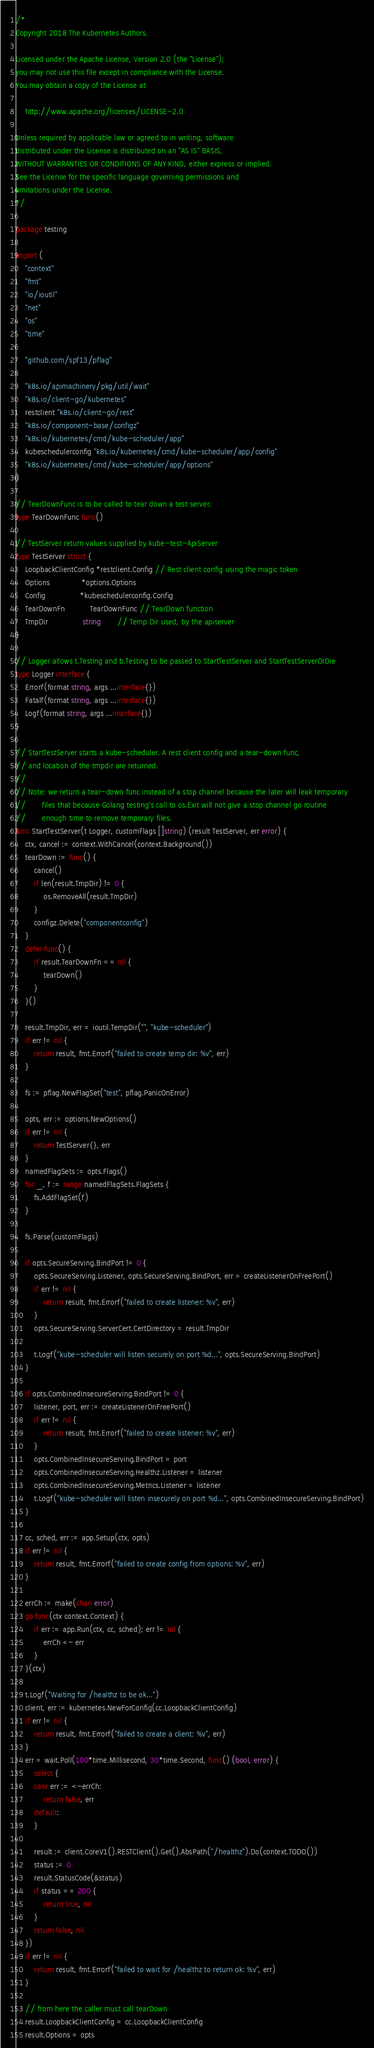Convert code to text. <code><loc_0><loc_0><loc_500><loc_500><_Go_>/*
Copyright 2018 The Kubernetes Authors.

Licensed under the Apache License, Version 2.0 (the "License");
you may not use this file except in compliance with the License.
You may obtain a copy of the License at

    http://www.apache.org/licenses/LICENSE-2.0

Unless required by applicable law or agreed to in writing, software
distributed under the License is distributed on an "AS IS" BASIS,
WITHOUT WARRANTIES OR CONDITIONS OF ANY KIND, either express or implied.
See the License for the specific language governing permissions and
limitations under the License.
*/

package testing

import (
	"context"
	"fmt"
	"io/ioutil"
	"net"
	"os"
	"time"

	"github.com/spf13/pflag"

	"k8s.io/apimachinery/pkg/util/wait"
	"k8s.io/client-go/kubernetes"
	restclient "k8s.io/client-go/rest"
	"k8s.io/component-base/configz"
	"k8s.io/kubernetes/cmd/kube-scheduler/app"
	kubeschedulerconfig "k8s.io/kubernetes/cmd/kube-scheduler/app/config"
	"k8s.io/kubernetes/cmd/kube-scheduler/app/options"
)

// TearDownFunc is to be called to tear down a test server.
type TearDownFunc func()

// TestServer return values supplied by kube-test-ApiServer
type TestServer struct {
	LoopbackClientConfig *restclient.Config // Rest client config using the magic token
	Options              *options.Options
	Config               *kubeschedulerconfig.Config
	TearDownFn           TearDownFunc // TearDown function
	TmpDir               string       // Temp Dir used, by the apiserver
}

// Logger allows t.Testing and b.Testing to be passed to StartTestServer and StartTestServerOrDie
type Logger interface {
	Errorf(format string, args ...interface{})
	Fatalf(format string, args ...interface{})
	Logf(format string, args ...interface{})
}

// StartTestServer starts a kube-scheduler. A rest client config and a tear-down func,
// and location of the tmpdir are returned.
//
// Note: we return a tear-down func instead of a stop channel because the later will leak temporary
// 		 files that because Golang testing's call to os.Exit will not give a stop channel go routine
// 		 enough time to remove temporary files.
func StartTestServer(t Logger, customFlags []string) (result TestServer, err error) {
	ctx, cancel := context.WithCancel(context.Background())
	tearDown := func() {
		cancel()
		if len(result.TmpDir) != 0 {
			os.RemoveAll(result.TmpDir)
		}
		configz.Delete("componentconfig")
	}
	defer func() {
		if result.TearDownFn == nil {
			tearDown()
		}
	}()

	result.TmpDir, err = ioutil.TempDir("", "kube-scheduler")
	if err != nil {
		return result, fmt.Errorf("failed to create temp dir: %v", err)
	}

	fs := pflag.NewFlagSet("test", pflag.PanicOnError)

	opts, err := options.NewOptions()
	if err != nil {
		return TestServer{}, err
	}
	namedFlagSets := opts.Flags()
	for _, f := range namedFlagSets.FlagSets {
		fs.AddFlagSet(f)
	}

	fs.Parse(customFlags)

	if opts.SecureServing.BindPort != 0 {
		opts.SecureServing.Listener, opts.SecureServing.BindPort, err = createListenerOnFreePort()
		if err != nil {
			return result, fmt.Errorf("failed to create listener: %v", err)
		}
		opts.SecureServing.ServerCert.CertDirectory = result.TmpDir

		t.Logf("kube-scheduler will listen securely on port %d...", opts.SecureServing.BindPort)
	}

	if opts.CombinedInsecureServing.BindPort != 0 {
		listener, port, err := createListenerOnFreePort()
		if err != nil {
			return result, fmt.Errorf("failed to create listener: %v", err)
		}
		opts.CombinedInsecureServing.BindPort = port
		opts.CombinedInsecureServing.Healthz.Listener = listener
		opts.CombinedInsecureServing.Metrics.Listener = listener
		t.Logf("kube-scheduler will listen insecurely on port %d...", opts.CombinedInsecureServing.BindPort)
	}

	cc, sched, err := app.Setup(ctx, opts)
	if err != nil {
		return result, fmt.Errorf("failed to create config from options: %v", err)
	}

	errCh := make(chan error)
	go func(ctx context.Context) {
		if err := app.Run(ctx, cc, sched); err != nil {
			errCh <- err
		}
	}(ctx)

	t.Logf("Waiting for /healthz to be ok...")
	client, err := kubernetes.NewForConfig(cc.LoopbackClientConfig)
	if err != nil {
		return result, fmt.Errorf("failed to create a client: %v", err)
	}
	err = wait.Poll(100*time.Millisecond, 30*time.Second, func() (bool, error) {
		select {
		case err := <-errCh:
			return false, err
		default:
		}

		result := client.CoreV1().RESTClient().Get().AbsPath("/healthz").Do(context.TODO())
		status := 0
		result.StatusCode(&status)
		if status == 200 {
			return true, nil
		}
		return false, nil
	})
	if err != nil {
		return result, fmt.Errorf("failed to wait for /healthz to return ok: %v", err)
	}

	// from here the caller must call tearDown
	result.LoopbackClientConfig = cc.LoopbackClientConfig
	result.Options = opts</code> 